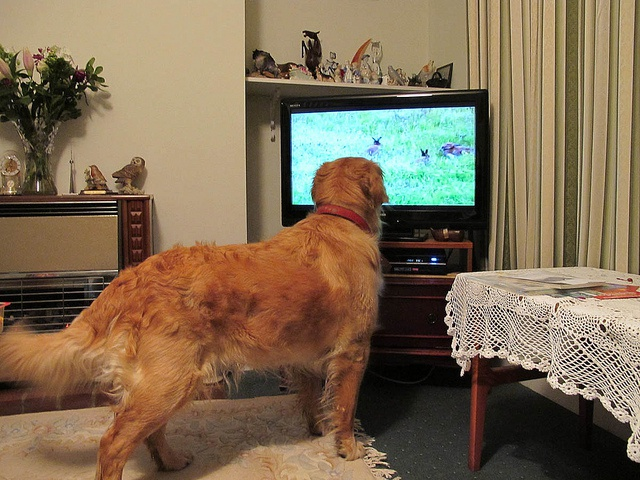Describe the objects in this image and their specific colors. I can see dog in tan, brown, maroon, and gray tones, dining table in tan, ivory, darkgray, and black tones, tv in tan, cyan, black, turquoise, and lightblue tones, vase in tan, black, and gray tones, and book in tan tones in this image. 